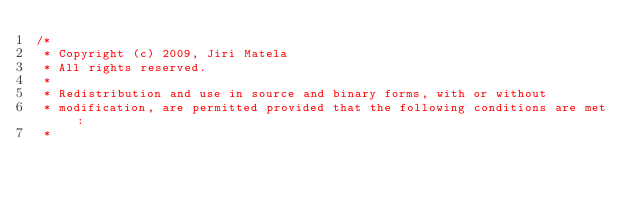Convert code to text. <code><loc_0><loc_0><loc_500><loc_500><_Cuda_>/* 
 * Copyright (c) 2009, Jiri Matela
 * All rights reserved.
 * 
 * Redistribution and use in source and binary forms, with or without
 * modification, are permitted provided that the following conditions are met:
 * </code> 